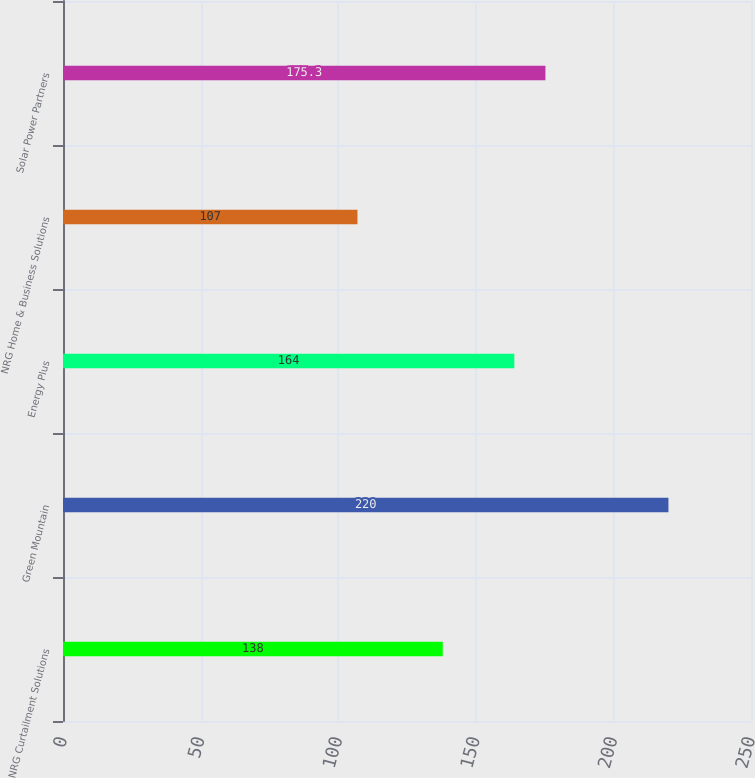Convert chart to OTSL. <chart><loc_0><loc_0><loc_500><loc_500><bar_chart><fcel>NRG Curtailment Solutions<fcel>Green Mountain<fcel>Energy Plus<fcel>NRG Home & Business Solutions<fcel>Solar Power Partners<nl><fcel>138<fcel>220<fcel>164<fcel>107<fcel>175.3<nl></chart> 